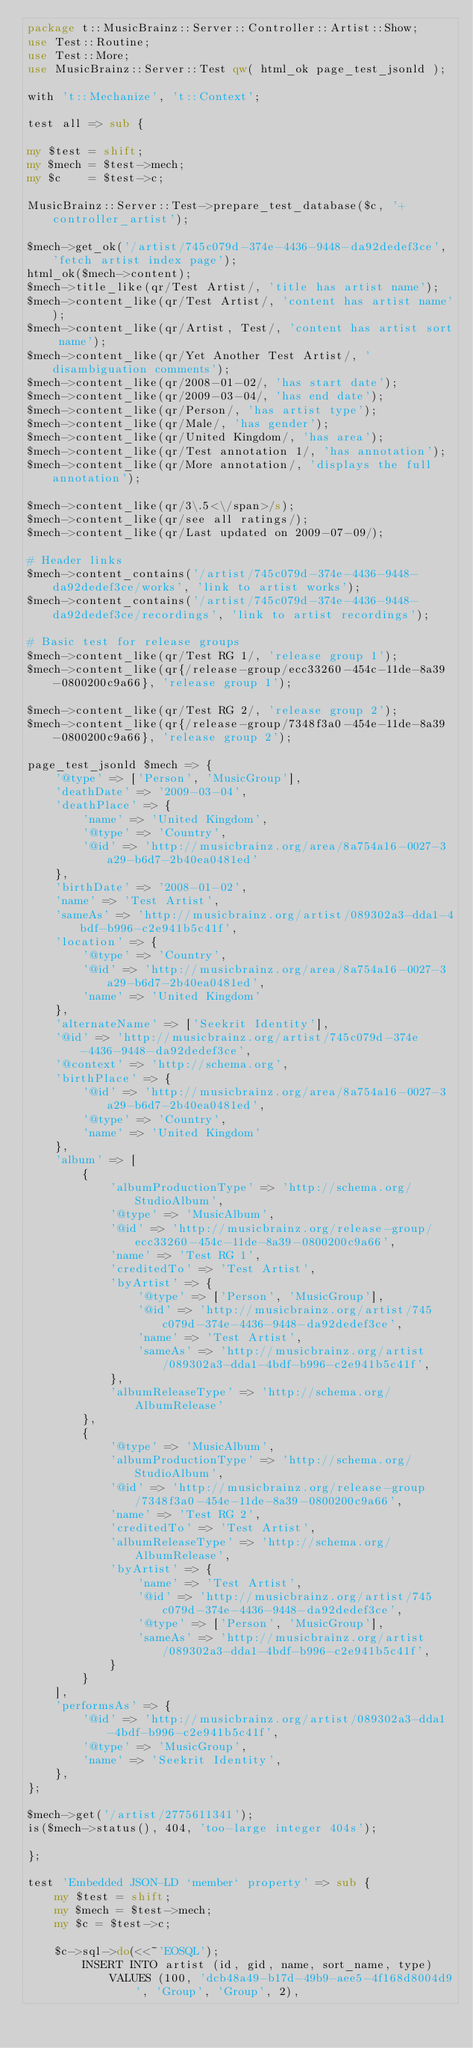<code> <loc_0><loc_0><loc_500><loc_500><_Perl_>package t::MusicBrainz::Server::Controller::Artist::Show;
use Test::Routine;
use Test::More;
use MusicBrainz::Server::Test qw( html_ok page_test_jsonld );

with 't::Mechanize', 't::Context';

test all => sub {

my $test = shift;
my $mech = $test->mech;
my $c    = $test->c;

MusicBrainz::Server::Test->prepare_test_database($c, '+controller_artist');

$mech->get_ok('/artist/745c079d-374e-4436-9448-da92dedef3ce', 'fetch artist index page');
html_ok($mech->content);
$mech->title_like(qr/Test Artist/, 'title has artist name');
$mech->content_like(qr/Test Artist/, 'content has artist name');
$mech->content_like(qr/Artist, Test/, 'content has artist sort name');
$mech->content_like(qr/Yet Another Test Artist/, 'disambiguation comments');
$mech->content_like(qr/2008-01-02/, 'has start date');
$mech->content_like(qr/2009-03-04/, 'has end date');
$mech->content_like(qr/Person/, 'has artist type');
$mech->content_like(qr/Male/, 'has gender');
$mech->content_like(qr/United Kingdom/, 'has area');
$mech->content_like(qr/Test annotation 1/, 'has annotation');
$mech->content_like(qr/More annotation/, 'displays the full annotation');

$mech->content_like(qr/3\.5<\/span>/s);
$mech->content_like(qr/see all ratings/);
$mech->content_like(qr/Last updated on 2009-07-09/);

# Header links
$mech->content_contains('/artist/745c079d-374e-4436-9448-da92dedef3ce/works', 'link to artist works');
$mech->content_contains('/artist/745c079d-374e-4436-9448-da92dedef3ce/recordings', 'link to artist recordings');

# Basic test for release groups
$mech->content_like(qr/Test RG 1/, 'release group 1');
$mech->content_like(qr{/release-group/ecc33260-454c-11de-8a39-0800200c9a66}, 'release group 1');

$mech->content_like(qr/Test RG 2/, 'release group 2');
$mech->content_like(qr{/release-group/7348f3a0-454e-11de-8a39-0800200c9a66}, 'release group 2');

page_test_jsonld $mech => {
    '@type' => ['Person', 'MusicGroup'],
    'deathDate' => '2009-03-04',
    'deathPlace' => {
        'name' => 'United Kingdom',
        '@type' => 'Country',
        '@id' => 'http://musicbrainz.org/area/8a754a16-0027-3a29-b6d7-2b40ea0481ed'
    },
    'birthDate' => '2008-01-02',
    'name' => 'Test Artist',
    'sameAs' => 'http://musicbrainz.org/artist/089302a3-dda1-4bdf-b996-c2e941b5c41f',
    'location' => {
        '@type' => 'Country',
        '@id' => 'http://musicbrainz.org/area/8a754a16-0027-3a29-b6d7-2b40ea0481ed',
        'name' => 'United Kingdom'
    },
    'alternateName' => ['Seekrit Identity'],
    '@id' => 'http://musicbrainz.org/artist/745c079d-374e-4436-9448-da92dedef3ce',
    '@context' => 'http://schema.org',
    'birthPlace' => {
        '@id' => 'http://musicbrainz.org/area/8a754a16-0027-3a29-b6d7-2b40ea0481ed',
        '@type' => 'Country',
        'name' => 'United Kingdom'
    },
    'album' => [
        {
            'albumProductionType' => 'http://schema.org/StudioAlbum',
            '@type' => 'MusicAlbum',
            '@id' => 'http://musicbrainz.org/release-group/ecc33260-454c-11de-8a39-0800200c9a66',
            'name' => 'Test RG 1',
            'creditedTo' => 'Test Artist',
            'byArtist' => {
                '@type' => ['Person', 'MusicGroup'],
                '@id' => 'http://musicbrainz.org/artist/745c079d-374e-4436-9448-da92dedef3ce',
                'name' => 'Test Artist',
                'sameAs' => 'http://musicbrainz.org/artist/089302a3-dda1-4bdf-b996-c2e941b5c41f',
            },
            'albumReleaseType' => 'http://schema.org/AlbumRelease'
        },
        {
            '@type' => 'MusicAlbum',
            'albumProductionType' => 'http://schema.org/StudioAlbum',
            '@id' => 'http://musicbrainz.org/release-group/7348f3a0-454e-11de-8a39-0800200c9a66',
            'name' => 'Test RG 2',
            'creditedTo' => 'Test Artist',
            'albumReleaseType' => 'http://schema.org/AlbumRelease',
            'byArtist' => {
                'name' => 'Test Artist',
                '@id' => 'http://musicbrainz.org/artist/745c079d-374e-4436-9448-da92dedef3ce',
                '@type' => ['Person', 'MusicGroup'],
                'sameAs' => 'http://musicbrainz.org/artist/089302a3-dda1-4bdf-b996-c2e941b5c41f',
            }
        }
    ],
    'performsAs' => {
        '@id' => 'http://musicbrainz.org/artist/089302a3-dda1-4bdf-b996-c2e941b5c41f',
        '@type' => 'MusicGroup',
        'name' => 'Seekrit Identity',
    },
};

$mech->get('/artist/2775611341');
is($mech->status(), 404, 'too-large integer 404s');

};

test 'Embedded JSON-LD `member` property' => sub {
    my $test = shift;
    my $mech = $test->mech;
    my $c = $test->c;

    $c->sql->do(<<~'EOSQL');
        INSERT INTO artist (id, gid, name, sort_name, type)
            VALUES (100, 'dcb48a49-b17d-49b9-aee5-4f168d8004d9', 'Group', 'Group', 2),</code> 